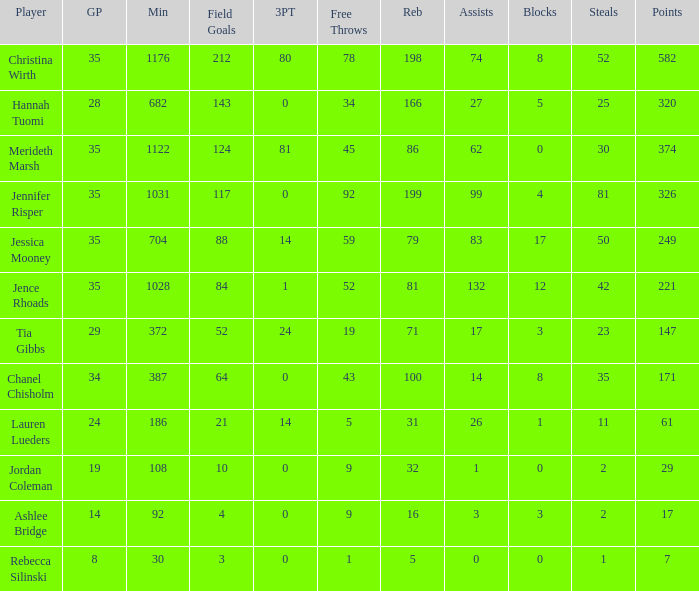How many blockings occured in the game with 198 rebounds? 8.0. 